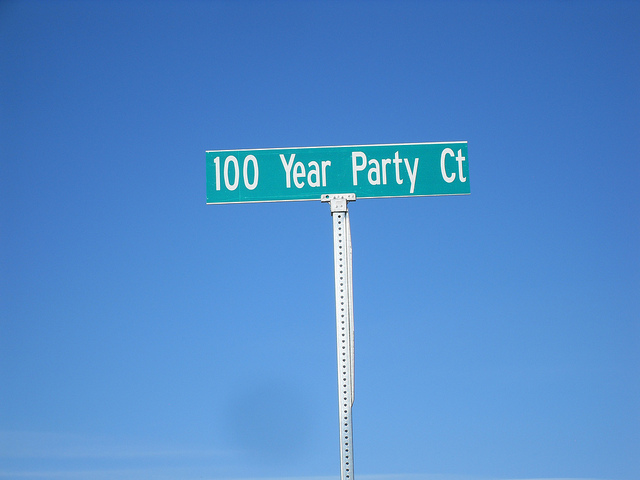<image>What type of cloud is behind the sign? I am not sure what type of cloud is behind the sign. It could be cirrus but it is also possible that there is no cloud. What type of cloud is behind the sign? I don't know what type of cloud is behind the sign. There doesn't seem to be any cloud visible. 